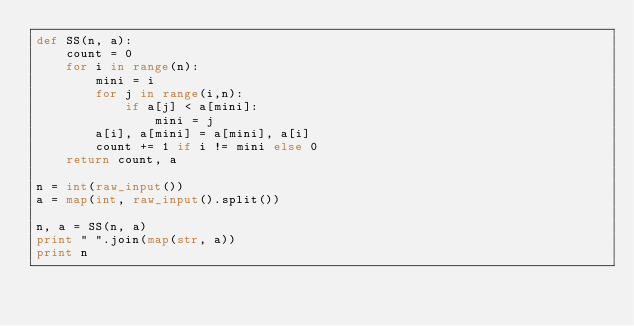Convert code to text. <code><loc_0><loc_0><loc_500><loc_500><_Python_>def SS(n, a):
    count = 0
    for i in range(n):
        mini = i
        for j in range(i,n):
            if a[j] < a[mini]:
                mini = j
        a[i], a[mini] = a[mini], a[i]
        count += 1 if i != mini else 0
    return count, a
    
n = int(raw_input())
a = map(int, raw_input().split())

n, a = SS(n, a)
print " ".join(map(str, a))
print n</code> 